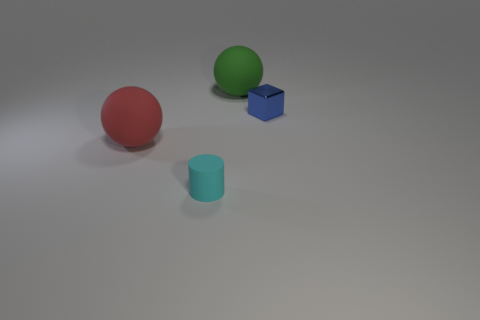Are there any other things that have the same color as the small rubber cylinder?
Offer a terse response. No. Is there any other thing that has the same material as the small block?
Offer a very short reply. No. What material is the tiny object right of the big green ball?
Ensure brevity in your answer.  Metal. Is there a cyan matte cylinder that has the same size as the cyan thing?
Give a very brief answer. No. There is a large red rubber object; is it the same shape as the big matte object behind the blue object?
Your response must be concise. Yes. Are there fewer green matte things in front of the green matte object than brown objects?
Offer a very short reply. No. Is the green matte thing the same shape as the cyan object?
Make the answer very short. No. What is the size of the cylinder that is the same material as the red object?
Give a very brief answer. Small. Is the number of big red metallic cylinders less than the number of large red balls?
Your answer should be very brief. Yes. What number of big things are brown metallic balls or cyan cylinders?
Ensure brevity in your answer.  0. 